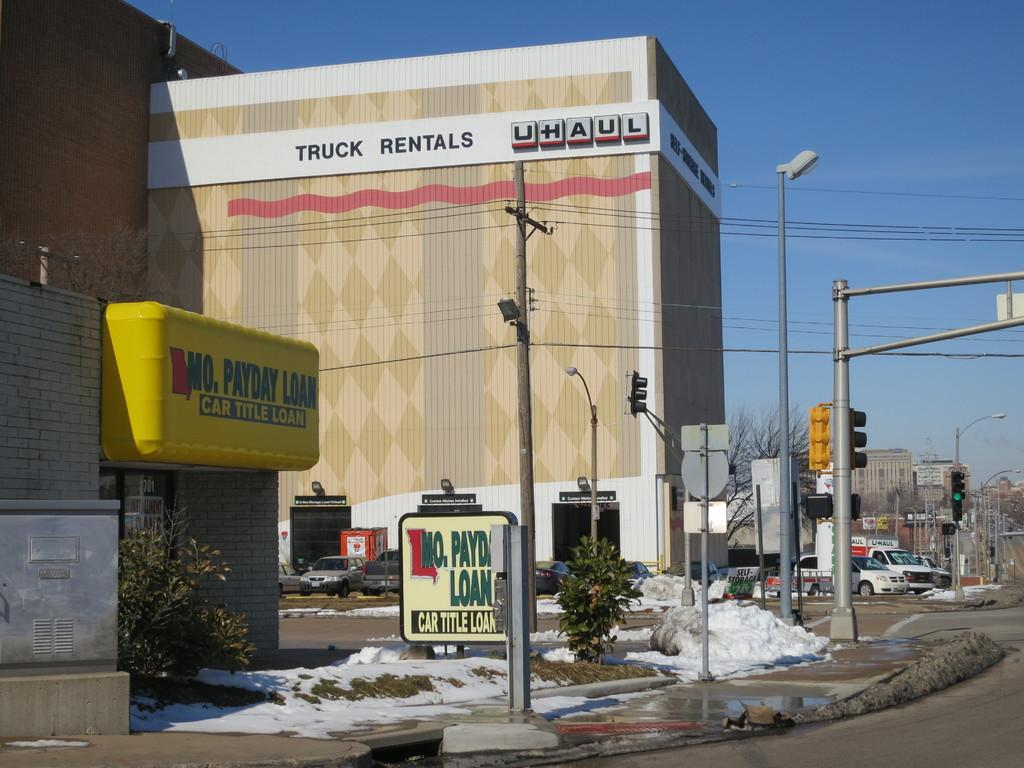What structures are present in the image? There are poles, traffic signal lights, trees, buildings, and vehicles on the roads visible in the image. What is the weather like in the image? There is snow visible in the image, indicating a cold or wintry weather condition. What can be seen in the background of the image? The sky is visible in the background of the image. What type of food is being cooked in the image? There is no indication of food or cooking in the image. What happens when the traffic signal lights burst in the image? There is no mention of traffic signal lights bursting in the image; they are functioning as intended. 